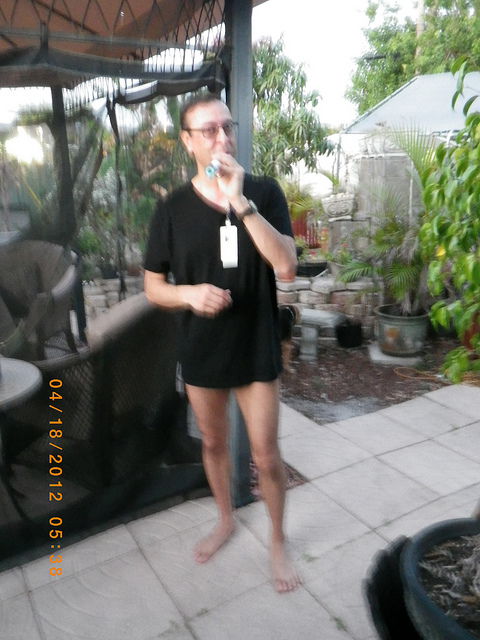Extract all visible text content from this image. 04 18 2012 05 